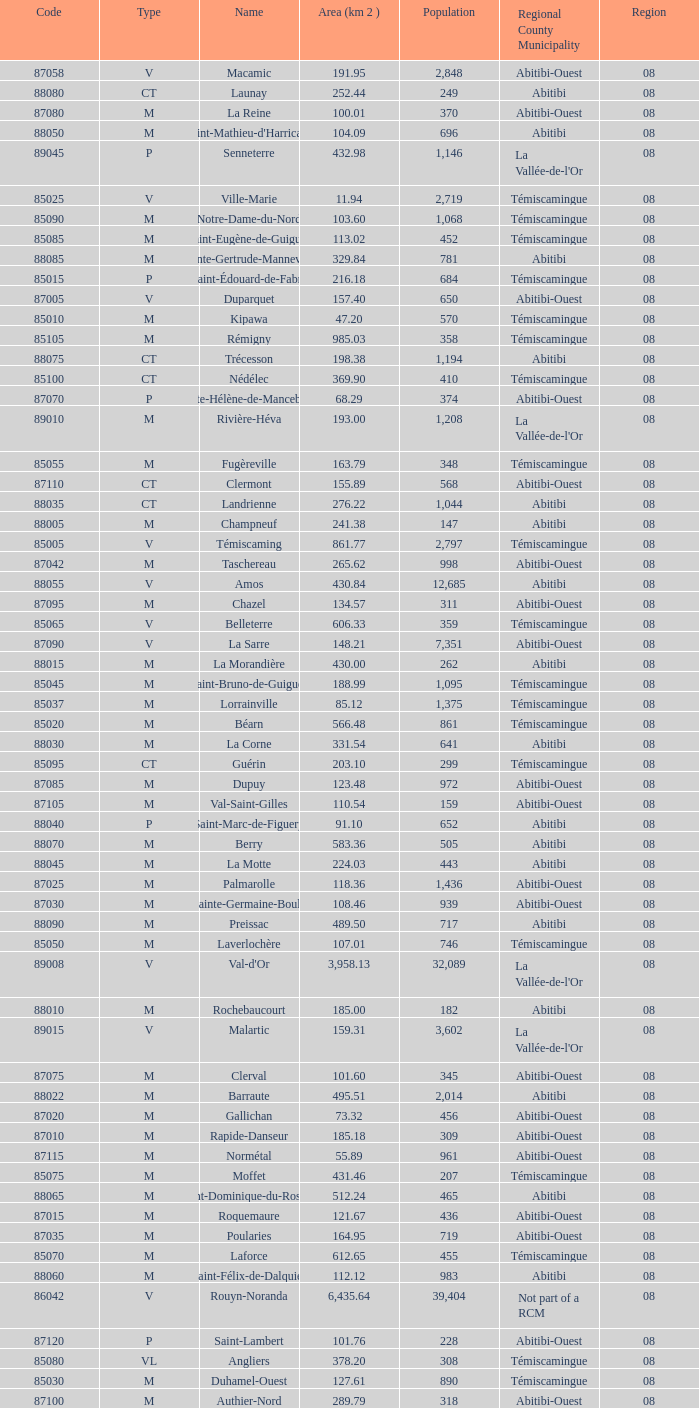What is Dupuy lowest area in km2? 123.48. 